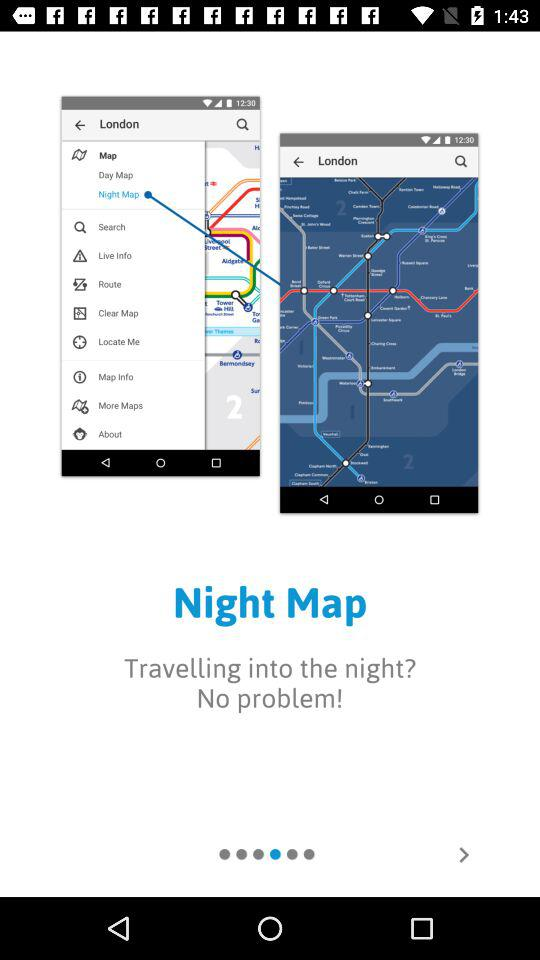Which city is showing on the application? The city is London. 